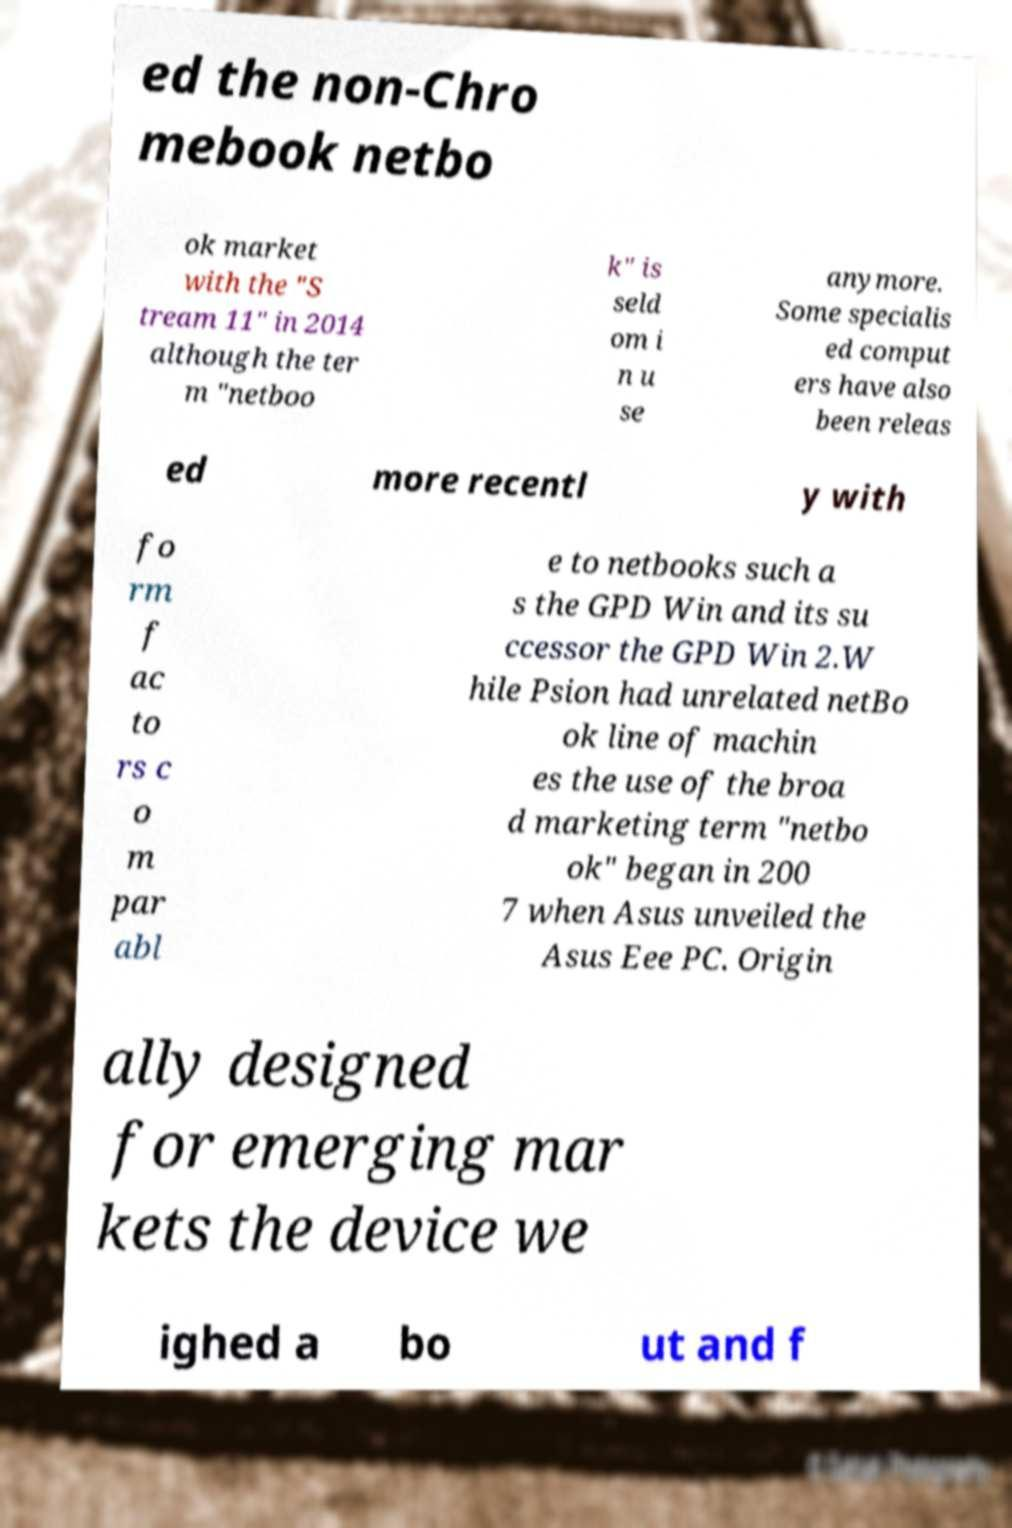Please identify and transcribe the text found in this image. ed the non-Chro mebook netbo ok market with the "S tream 11" in 2014 although the ter m "netboo k" is seld om i n u se anymore. Some specialis ed comput ers have also been releas ed more recentl y with fo rm f ac to rs c o m par abl e to netbooks such a s the GPD Win and its su ccessor the GPD Win 2.W hile Psion had unrelated netBo ok line of machin es the use of the broa d marketing term "netbo ok" began in 200 7 when Asus unveiled the Asus Eee PC. Origin ally designed for emerging mar kets the device we ighed a bo ut and f 